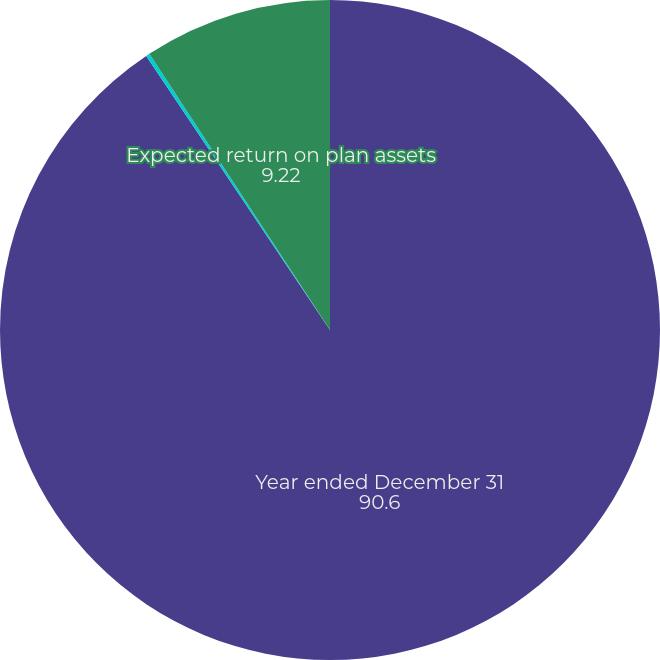Convert chart. <chart><loc_0><loc_0><loc_500><loc_500><pie_chart><fcel>Year ended December 31<fcel>Discount rate<fcel>Expected return on plan assets<nl><fcel>90.6%<fcel>0.18%<fcel>9.22%<nl></chart> 